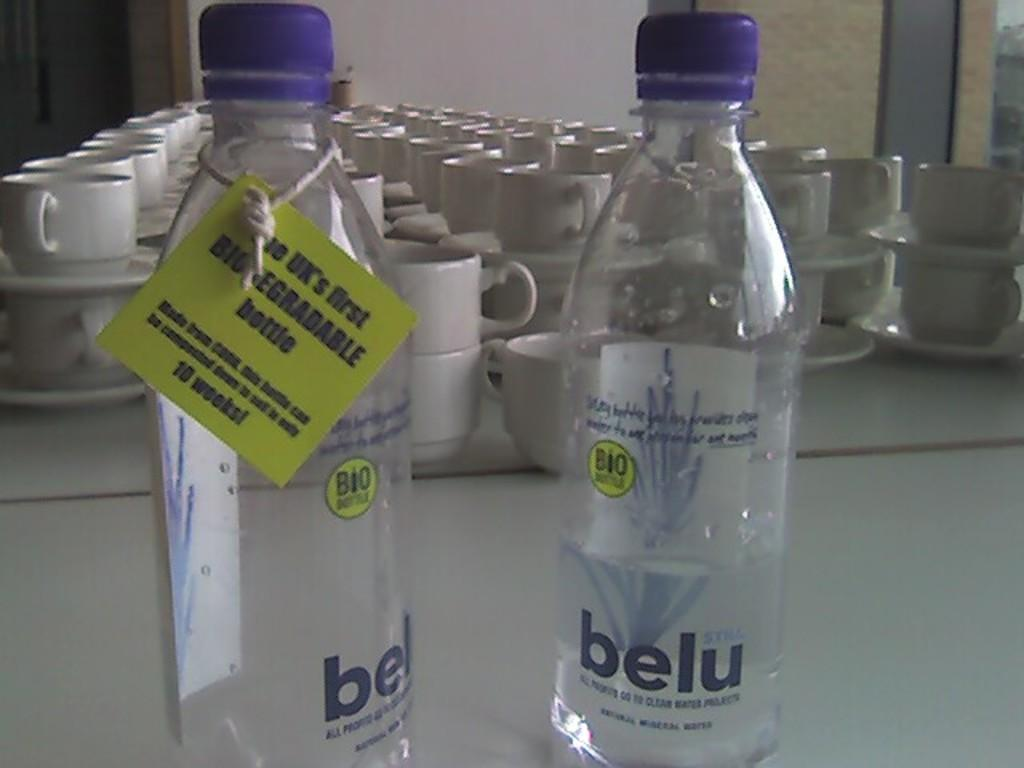What piece of furniture is present in the image? There is a table in the image. What items can be seen on the table? There are two bottles and cups on the table. How many apples are on the table in the image? There is no mention of apples in the image, so we cannot determine the number of apples present. 